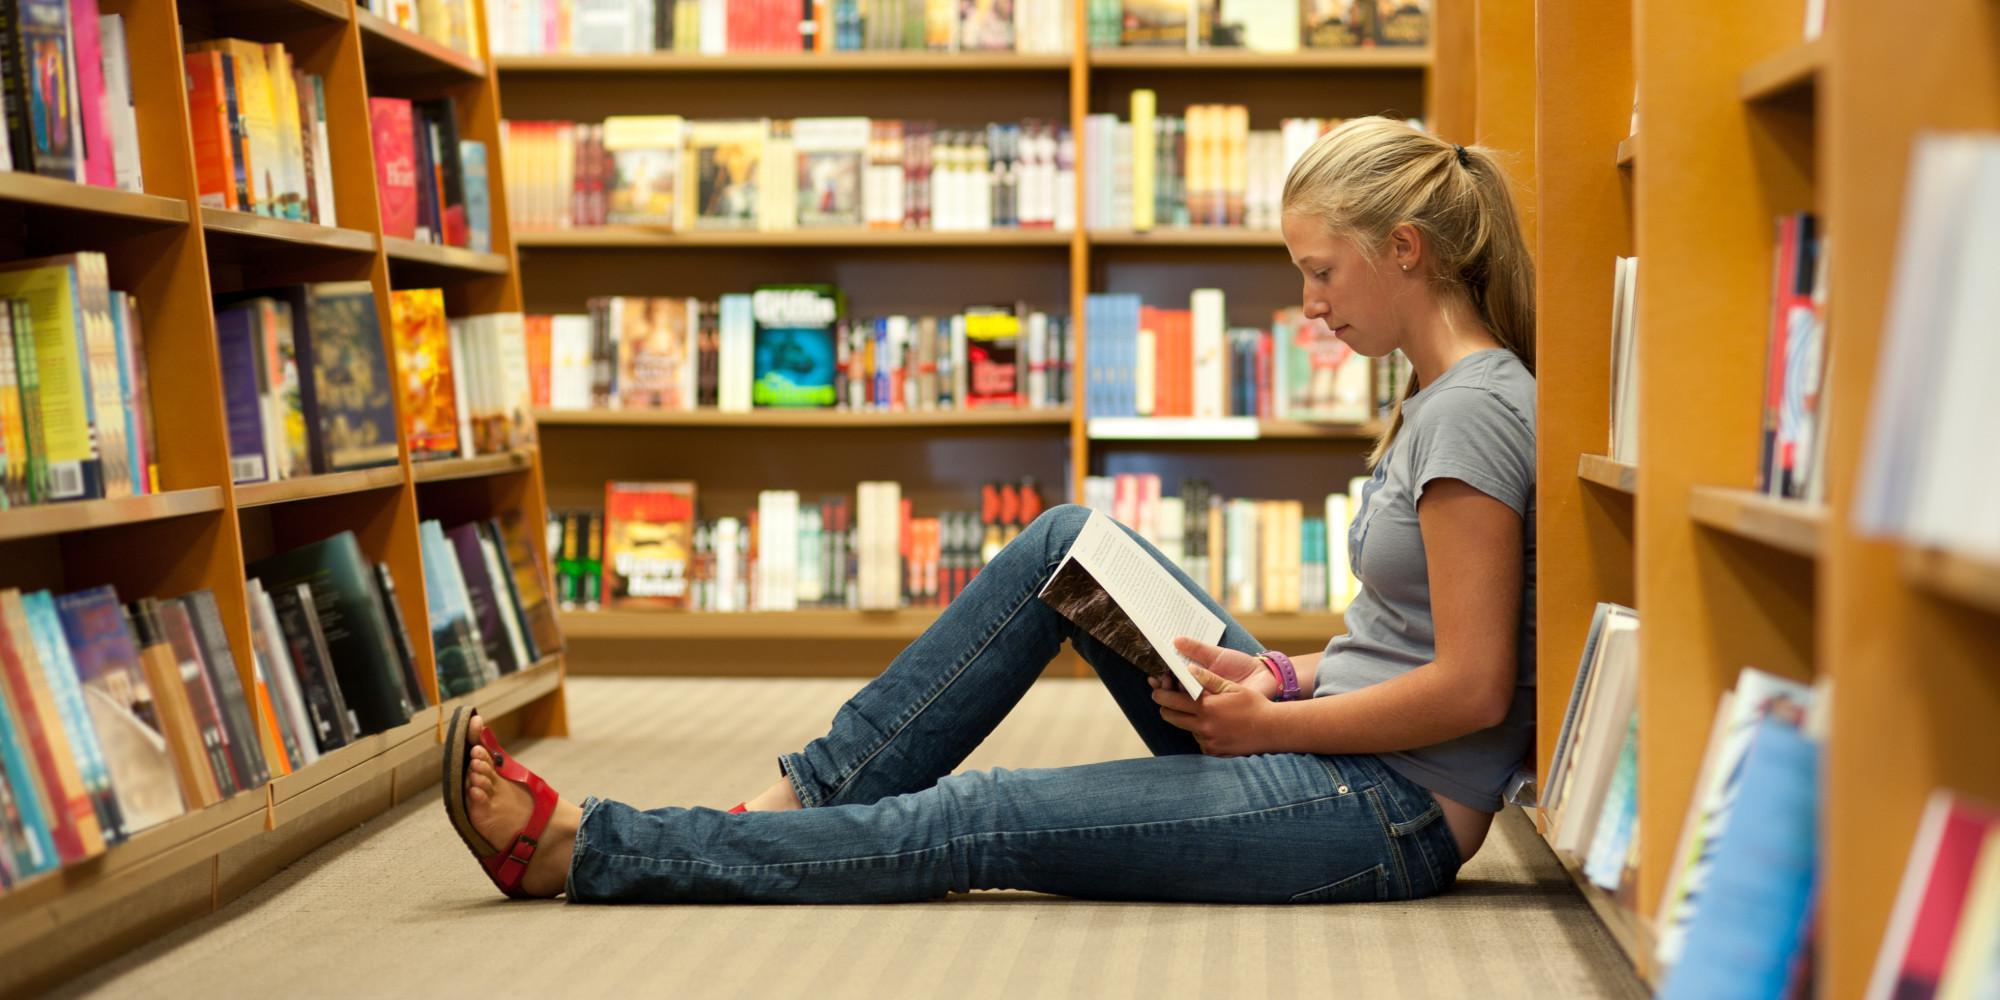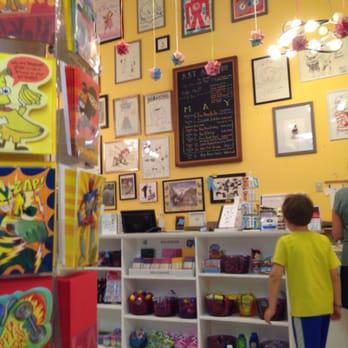The first image is the image on the left, the second image is the image on the right. Analyze the images presented: Is the assertion "One image shows a back-turned person standing in front of shelves at the right of the scene, and the other image includes at least one person sitting with a leg extended on the floor and back to the right." valid? Answer yes or no. Yes. The first image is the image on the left, the second image is the image on the right. Evaluate the accuracy of this statement regarding the images: "In at least one image there is a male child looking at yellow painted walls in the bookstore.". Is it true? Answer yes or no. Yes. 